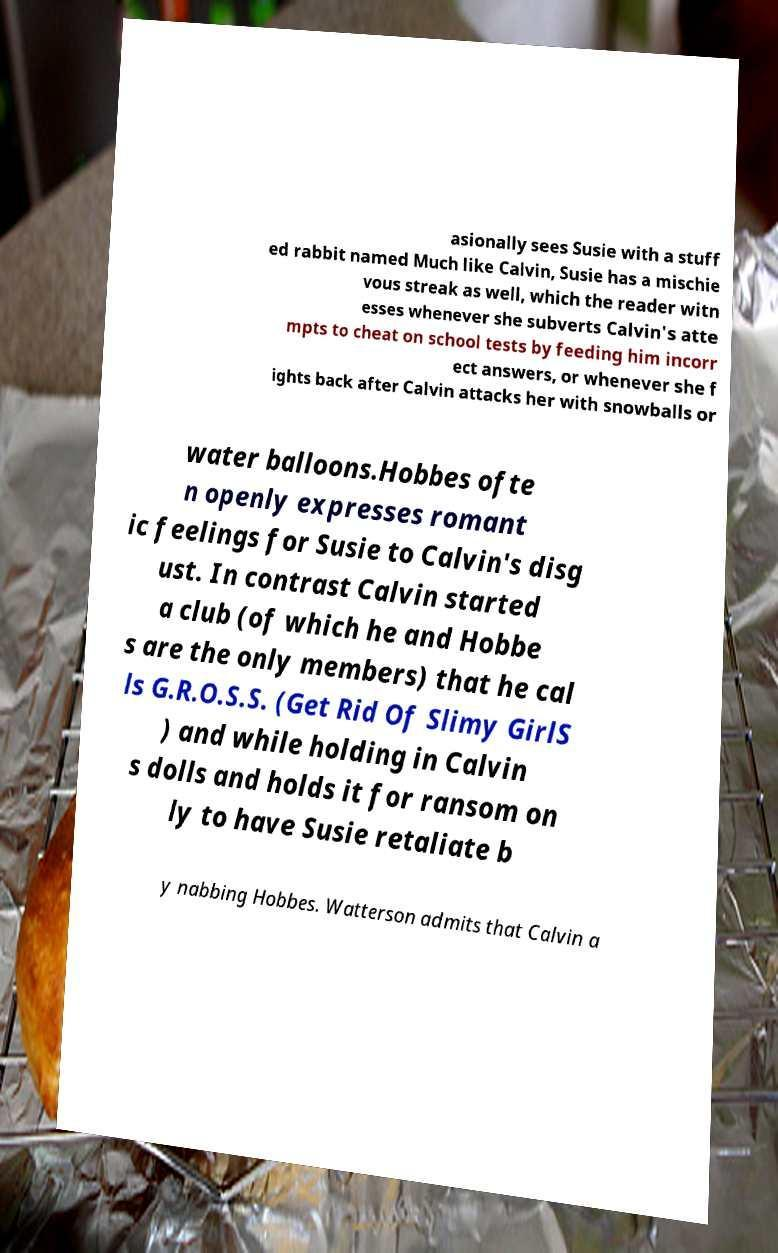Could you extract and type out the text from this image? asionally sees Susie with a stuff ed rabbit named Much like Calvin, Susie has a mischie vous streak as well, which the reader witn esses whenever she subverts Calvin's atte mpts to cheat on school tests by feeding him incorr ect answers, or whenever she f ights back after Calvin attacks her with snowballs or water balloons.Hobbes ofte n openly expresses romant ic feelings for Susie to Calvin's disg ust. In contrast Calvin started a club (of which he and Hobbe s are the only members) that he cal ls G.R.O.S.S. (Get Rid Of Slimy GirlS ) and while holding in Calvin s dolls and holds it for ransom on ly to have Susie retaliate b y nabbing Hobbes. Watterson admits that Calvin a 